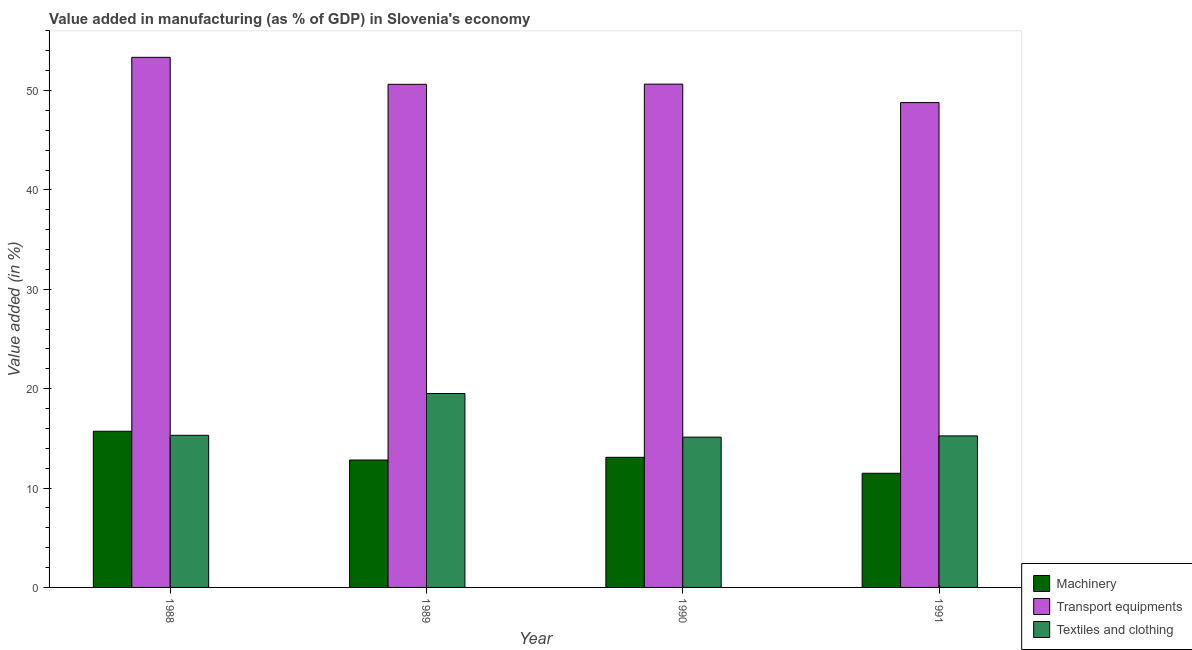How many different coloured bars are there?
Give a very brief answer. 3. Are the number of bars per tick equal to the number of legend labels?
Ensure brevity in your answer.  Yes. Are the number of bars on each tick of the X-axis equal?
Provide a succinct answer. Yes. What is the value added in manufacturing textile and clothing in 1991?
Your response must be concise. 15.25. Across all years, what is the maximum value added in manufacturing machinery?
Your answer should be very brief. 15.72. Across all years, what is the minimum value added in manufacturing transport equipments?
Offer a very short reply. 48.79. In which year was the value added in manufacturing machinery minimum?
Your response must be concise. 1991. What is the total value added in manufacturing transport equipments in the graph?
Your answer should be compact. 203.41. What is the difference between the value added in manufacturing machinery in 1988 and that in 1991?
Provide a short and direct response. 4.23. What is the difference between the value added in manufacturing machinery in 1988 and the value added in manufacturing textile and clothing in 1991?
Provide a short and direct response. 4.23. What is the average value added in manufacturing transport equipments per year?
Offer a terse response. 50.85. In how many years, is the value added in manufacturing machinery greater than 12 %?
Make the answer very short. 3. What is the ratio of the value added in manufacturing machinery in 1989 to that in 1991?
Make the answer very short. 1.12. Is the value added in manufacturing textile and clothing in 1989 less than that in 1990?
Your response must be concise. No. Is the difference between the value added in manufacturing transport equipments in 1989 and 1991 greater than the difference between the value added in manufacturing textile and clothing in 1989 and 1991?
Your answer should be compact. No. What is the difference between the highest and the second highest value added in manufacturing machinery?
Keep it short and to the point. 2.62. What is the difference between the highest and the lowest value added in manufacturing machinery?
Provide a succinct answer. 4.23. In how many years, is the value added in manufacturing machinery greater than the average value added in manufacturing machinery taken over all years?
Ensure brevity in your answer.  1. Is the sum of the value added in manufacturing transport equipments in 1989 and 1990 greater than the maximum value added in manufacturing textile and clothing across all years?
Provide a succinct answer. Yes. What does the 3rd bar from the left in 1990 represents?
Offer a very short reply. Textiles and clothing. What does the 2nd bar from the right in 1991 represents?
Ensure brevity in your answer.  Transport equipments. Is it the case that in every year, the sum of the value added in manufacturing machinery and value added in manufacturing transport equipments is greater than the value added in manufacturing textile and clothing?
Offer a terse response. Yes. How many bars are there?
Provide a succinct answer. 12. Are all the bars in the graph horizontal?
Your answer should be very brief. No. How many years are there in the graph?
Your answer should be very brief. 4. Does the graph contain grids?
Offer a very short reply. No. How many legend labels are there?
Your answer should be very brief. 3. What is the title of the graph?
Keep it short and to the point. Value added in manufacturing (as % of GDP) in Slovenia's economy. Does "Machinery" appear as one of the legend labels in the graph?
Offer a terse response. Yes. What is the label or title of the Y-axis?
Provide a short and direct response. Value added (in %). What is the Value added (in %) of Machinery in 1988?
Offer a terse response. 15.72. What is the Value added (in %) in Transport equipments in 1988?
Make the answer very short. 53.34. What is the Value added (in %) in Textiles and clothing in 1988?
Provide a short and direct response. 15.31. What is the Value added (in %) in Machinery in 1989?
Your answer should be compact. 12.82. What is the Value added (in %) of Transport equipments in 1989?
Your answer should be compact. 50.63. What is the Value added (in %) of Textiles and clothing in 1989?
Give a very brief answer. 19.51. What is the Value added (in %) in Machinery in 1990?
Make the answer very short. 13.09. What is the Value added (in %) of Transport equipments in 1990?
Your answer should be compact. 50.65. What is the Value added (in %) of Textiles and clothing in 1990?
Offer a terse response. 15.12. What is the Value added (in %) in Machinery in 1991?
Make the answer very short. 11.49. What is the Value added (in %) in Transport equipments in 1991?
Provide a short and direct response. 48.79. What is the Value added (in %) of Textiles and clothing in 1991?
Your response must be concise. 15.25. Across all years, what is the maximum Value added (in %) in Machinery?
Your answer should be very brief. 15.72. Across all years, what is the maximum Value added (in %) of Transport equipments?
Your answer should be compact. 53.34. Across all years, what is the maximum Value added (in %) in Textiles and clothing?
Your answer should be compact. 19.51. Across all years, what is the minimum Value added (in %) of Machinery?
Provide a succinct answer. 11.49. Across all years, what is the minimum Value added (in %) of Transport equipments?
Your response must be concise. 48.79. Across all years, what is the minimum Value added (in %) in Textiles and clothing?
Offer a very short reply. 15.12. What is the total Value added (in %) in Machinery in the graph?
Provide a succinct answer. 53.12. What is the total Value added (in %) in Transport equipments in the graph?
Offer a very short reply. 203.41. What is the total Value added (in %) in Textiles and clothing in the graph?
Offer a very short reply. 65.19. What is the difference between the Value added (in %) of Machinery in 1988 and that in 1989?
Keep it short and to the point. 2.9. What is the difference between the Value added (in %) in Transport equipments in 1988 and that in 1989?
Give a very brief answer. 2.72. What is the difference between the Value added (in %) of Textiles and clothing in 1988 and that in 1989?
Keep it short and to the point. -4.2. What is the difference between the Value added (in %) of Machinery in 1988 and that in 1990?
Ensure brevity in your answer.  2.62. What is the difference between the Value added (in %) of Transport equipments in 1988 and that in 1990?
Provide a succinct answer. 2.7. What is the difference between the Value added (in %) of Textiles and clothing in 1988 and that in 1990?
Provide a short and direct response. 0.18. What is the difference between the Value added (in %) in Machinery in 1988 and that in 1991?
Ensure brevity in your answer.  4.23. What is the difference between the Value added (in %) of Transport equipments in 1988 and that in 1991?
Ensure brevity in your answer.  4.55. What is the difference between the Value added (in %) of Textiles and clothing in 1988 and that in 1991?
Give a very brief answer. 0.06. What is the difference between the Value added (in %) of Machinery in 1989 and that in 1990?
Offer a very short reply. -0.27. What is the difference between the Value added (in %) of Transport equipments in 1989 and that in 1990?
Give a very brief answer. -0.02. What is the difference between the Value added (in %) in Textiles and clothing in 1989 and that in 1990?
Your response must be concise. 4.39. What is the difference between the Value added (in %) in Machinery in 1989 and that in 1991?
Provide a short and direct response. 1.33. What is the difference between the Value added (in %) of Transport equipments in 1989 and that in 1991?
Provide a succinct answer. 1.84. What is the difference between the Value added (in %) of Textiles and clothing in 1989 and that in 1991?
Keep it short and to the point. 4.26. What is the difference between the Value added (in %) in Machinery in 1990 and that in 1991?
Make the answer very short. 1.61. What is the difference between the Value added (in %) of Transport equipments in 1990 and that in 1991?
Give a very brief answer. 1.86. What is the difference between the Value added (in %) of Textiles and clothing in 1990 and that in 1991?
Keep it short and to the point. -0.13. What is the difference between the Value added (in %) of Machinery in 1988 and the Value added (in %) of Transport equipments in 1989?
Offer a terse response. -34.91. What is the difference between the Value added (in %) of Machinery in 1988 and the Value added (in %) of Textiles and clothing in 1989?
Keep it short and to the point. -3.8. What is the difference between the Value added (in %) of Transport equipments in 1988 and the Value added (in %) of Textiles and clothing in 1989?
Offer a very short reply. 33.83. What is the difference between the Value added (in %) in Machinery in 1988 and the Value added (in %) in Transport equipments in 1990?
Keep it short and to the point. -34.93. What is the difference between the Value added (in %) in Machinery in 1988 and the Value added (in %) in Textiles and clothing in 1990?
Provide a succinct answer. 0.59. What is the difference between the Value added (in %) of Transport equipments in 1988 and the Value added (in %) of Textiles and clothing in 1990?
Your answer should be very brief. 38.22. What is the difference between the Value added (in %) in Machinery in 1988 and the Value added (in %) in Transport equipments in 1991?
Your response must be concise. -33.07. What is the difference between the Value added (in %) of Machinery in 1988 and the Value added (in %) of Textiles and clothing in 1991?
Offer a terse response. 0.47. What is the difference between the Value added (in %) of Transport equipments in 1988 and the Value added (in %) of Textiles and clothing in 1991?
Offer a terse response. 38.09. What is the difference between the Value added (in %) in Machinery in 1989 and the Value added (in %) in Transport equipments in 1990?
Ensure brevity in your answer.  -37.83. What is the difference between the Value added (in %) of Machinery in 1989 and the Value added (in %) of Textiles and clothing in 1990?
Keep it short and to the point. -2.3. What is the difference between the Value added (in %) of Transport equipments in 1989 and the Value added (in %) of Textiles and clothing in 1990?
Offer a terse response. 35.51. What is the difference between the Value added (in %) of Machinery in 1989 and the Value added (in %) of Transport equipments in 1991?
Your answer should be very brief. -35.97. What is the difference between the Value added (in %) in Machinery in 1989 and the Value added (in %) in Textiles and clothing in 1991?
Your response must be concise. -2.43. What is the difference between the Value added (in %) of Transport equipments in 1989 and the Value added (in %) of Textiles and clothing in 1991?
Your response must be concise. 35.38. What is the difference between the Value added (in %) of Machinery in 1990 and the Value added (in %) of Transport equipments in 1991?
Your response must be concise. -35.7. What is the difference between the Value added (in %) of Machinery in 1990 and the Value added (in %) of Textiles and clothing in 1991?
Your response must be concise. -2.16. What is the difference between the Value added (in %) in Transport equipments in 1990 and the Value added (in %) in Textiles and clothing in 1991?
Give a very brief answer. 35.4. What is the average Value added (in %) in Machinery per year?
Provide a short and direct response. 13.28. What is the average Value added (in %) in Transport equipments per year?
Your response must be concise. 50.85. What is the average Value added (in %) in Textiles and clothing per year?
Offer a very short reply. 16.3. In the year 1988, what is the difference between the Value added (in %) in Machinery and Value added (in %) in Transport equipments?
Your answer should be very brief. -37.63. In the year 1988, what is the difference between the Value added (in %) in Machinery and Value added (in %) in Textiles and clothing?
Ensure brevity in your answer.  0.41. In the year 1988, what is the difference between the Value added (in %) of Transport equipments and Value added (in %) of Textiles and clothing?
Keep it short and to the point. 38.04. In the year 1989, what is the difference between the Value added (in %) of Machinery and Value added (in %) of Transport equipments?
Give a very brief answer. -37.81. In the year 1989, what is the difference between the Value added (in %) of Machinery and Value added (in %) of Textiles and clothing?
Provide a succinct answer. -6.69. In the year 1989, what is the difference between the Value added (in %) in Transport equipments and Value added (in %) in Textiles and clothing?
Provide a short and direct response. 31.12. In the year 1990, what is the difference between the Value added (in %) in Machinery and Value added (in %) in Transport equipments?
Keep it short and to the point. -37.55. In the year 1990, what is the difference between the Value added (in %) of Machinery and Value added (in %) of Textiles and clothing?
Offer a very short reply. -2.03. In the year 1990, what is the difference between the Value added (in %) of Transport equipments and Value added (in %) of Textiles and clothing?
Give a very brief answer. 35.52. In the year 1991, what is the difference between the Value added (in %) of Machinery and Value added (in %) of Transport equipments?
Give a very brief answer. -37.3. In the year 1991, what is the difference between the Value added (in %) in Machinery and Value added (in %) in Textiles and clothing?
Offer a terse response. -3.76. In the year 1991, what is the difference between the Value added (in %) of Transport equipments and Value added (in %) of Textiles and clothing?
Provide a short and direct response. 33.54. What is the ratio of the Value added (in %) in Machinery in 1988 to that in 1989?
Your response must be concise. 1.23. What is the ratio of the Value added (in %) in Transport equipments in 1988 to that in 1989?
Ensure brevity in your answer.  1.05. What is the ratio of the Value added (in %) in Textiles and clothing in 1988 to that in 1989?
Make the answer very short. 0.78. What is the ratio of the Value added (in %) of Machinery in 1988 to that in 1990?
Provide a short and direct response. 1.2. What is the ratio of the Value added (in %) in Transport equipments in 1988 to that in 1990?
Offer a terse response. 1.05. What is the ratio of the Value added (in %) of Textiles and clothing in 1988 to that in 1990?
Your response must be concise. 1.01. What is the ratio of the Value added (in %) of Machinery in 1988 to that in 1991?
Your response must be concise. 1.37. What is the ratio of the Value added (in %) of Transport equipments in 1988 to that in 1991?
Make the answer very short. 1.09. What is the ratio of the Value added (in %) of Textiles and clothing in 1988 to that in 1991?
Provide a short and direct response. 1. What is the ratio of the Value added (in %) in Machinery in 1989 to that in 1990?
Keep it short and to the point. 0.98. What is the ratio of the Value added (in %) in Transport equipments in 1989 to that in 1990?
Your answer should be very brief. 1. What is the ratio of the Value added (in %) of Textiles and clothing in 1989 to that in 1990?
Provide a short and direct response. 1.29. What is the ratio of the Value added (in %) of Machinery in 1989 to that in 1991?
Your response must be concise. 1.12. What is the ratio of the Value added (in %) in Transport equipments in 1989 to that in 1991?
Keep it short and to the point. 1.04. What is the ratio of the Value added (in %) in Textiles and clothing in 1989 to that in 1991?
Offer a very short reply. 1.28. What is the ratio of the Value added (in %) of Machinery in 1990 to that in 1991?
Ensure brevity in your answer.  1.14. What is the ratio of the Value added (in %) in Transport equipments in 1990 to that in 1991?
Keep it short and to the point. 1.04. What is the ratio of the Value added (in %) of Textiles and clothing in 1990 to that in 1991?
Provide a succinct answer. 0.99. What is the difference between the highest and the second highest Value added (in %) of Machinery?
Your response must be concise. 2.62. What is the difference between the highest and the second highest Value added (in %) in Transport equipments?
Offer a terse response. 2.7. What is the difference between the highest and the second highest Value added (in %) in Textiles and clothing?
Keep it short and to the point. 4.2. What is the difference between the highest and the lowest Value added (in %) of Machinery?
Give a very brief answer. 4.23. What is the difference between the highest and the lowest Value added (in %) of Transport equipments?
Provide a succinct answer. 4.55. What is the difference between the highest and the lowest Value added (in %) in Textiles and clothing?
Provide a short and direct response. 4.39. 